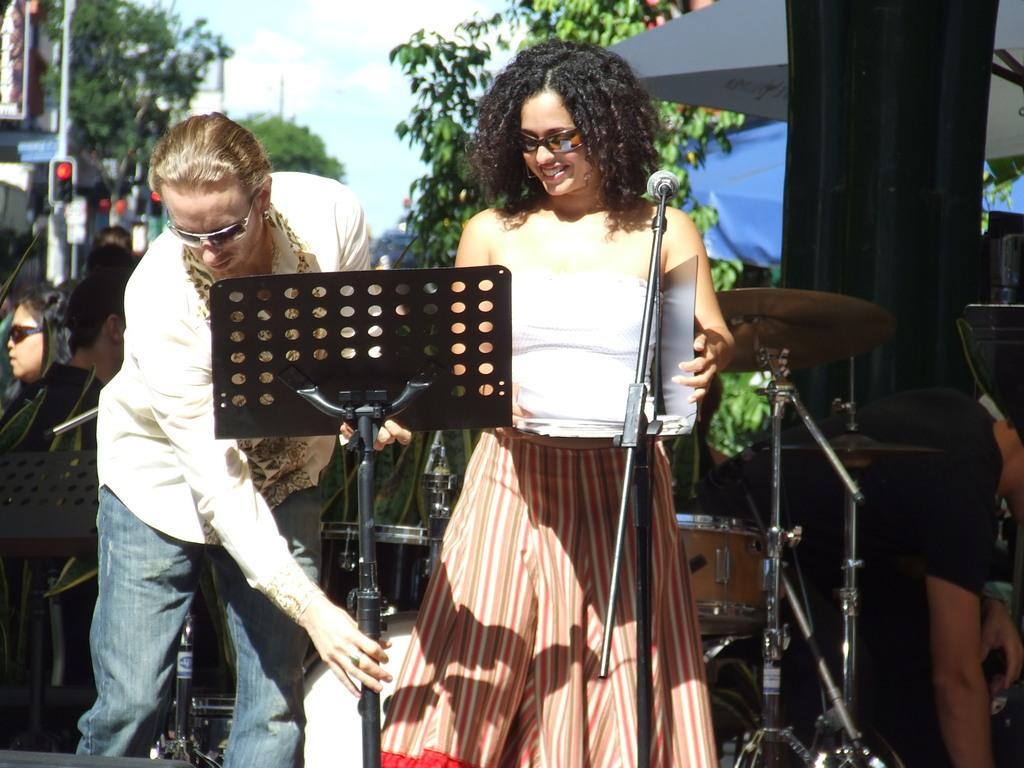Please provide a concise description of this image. On the left side, there is a person in white color shirt, wearing sun glasses and adjusting a stand. Beside him, there is a woman in white color t-shirt, wearing sun glasses, smiling and standing in front of a mic which is attached to a stand. In the background, there are other persons, there are trees, buildings and there are clouds in the blue sky. 